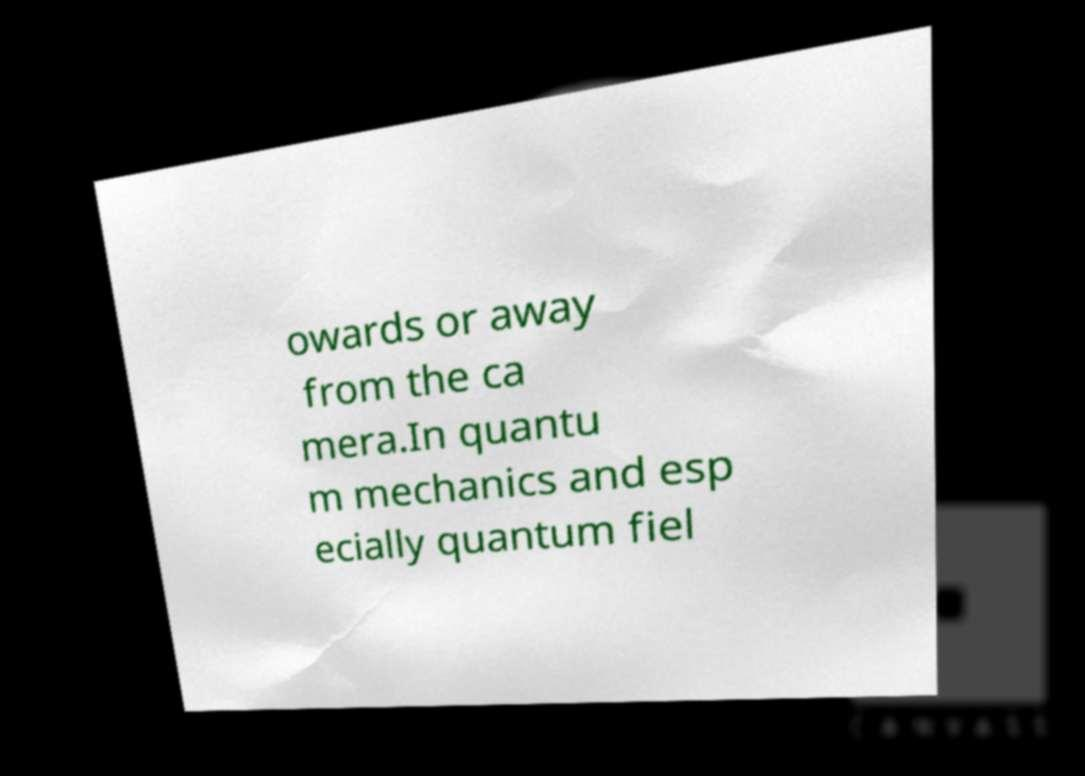There's text embedded in this image that I need extracted. Can you transcribe it verbatim? owards or away from the ca mera.In quantu m mechanics and esp ecially quantum fiel 